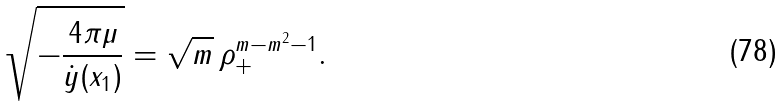Convert formula to latex. <formula><loc_0><loc_0><loc_500><loc_500>\sqrt { - \frac { 4 \pi \mu } { \dot { y } ( x _ { 1 } ) } } = \sqrt { m } \, \rho _ { + } ^ { m - m ^ { 2 } - 1 } .</formula> 